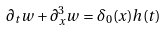Convert formula to latex. <formula><loc_0><loc_0><loc_500><loc_500>\partial _ { t } w + \partial _ { x } ^ { 3 } w = \delta _ { 0 } ( x ) h ( t )</formula> 